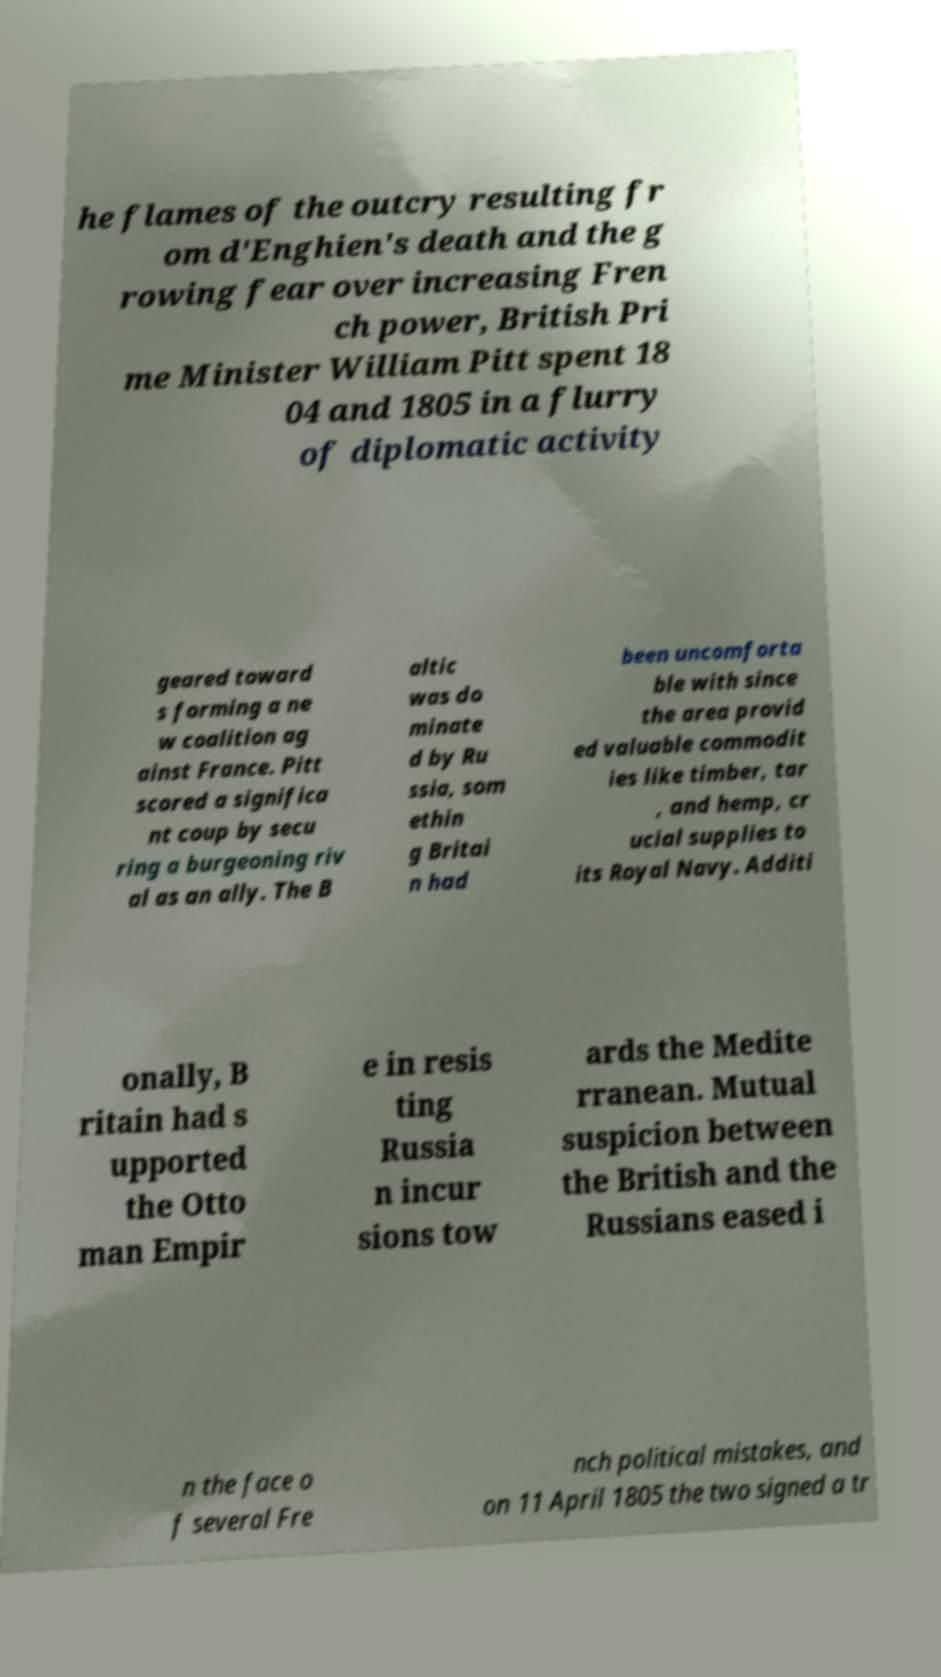Please identify and transcribe the text found in this image. he flames of the outcry resulting fr om d'Enghien's death and the g rowing fear over increasing Fren ch power, British Pri me Minister William Pitt spent 18 04 and 1805 in a flurry of diplomatic activity geared toward s forming a ne w coalition ag ainst France. Pitt scored a significa nt coup by secu ring a burgeoning riv al as an ally. The B altic was do minate d by Ru ssia, som ethin g Britai n had been uncomforta ble with since the area provid ed valuable commodit ies like timber, tar , and hemp, cr ucial supplies to its Royal Navy. Additi onally, B ritain had s upported the Otto man Empir e in resis ting Russia n incur sions tow ards the Medite rranean. Mutual suspicion between the British and the Russians eased i n the face o f several Fre nch political mistakes, and on 11 April 1805 the two signed a tr 